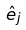Convert formula to latex. <formula><loc_0><loc_0><loc_500><loc_500>\hat { e } _ { j }</formula> 